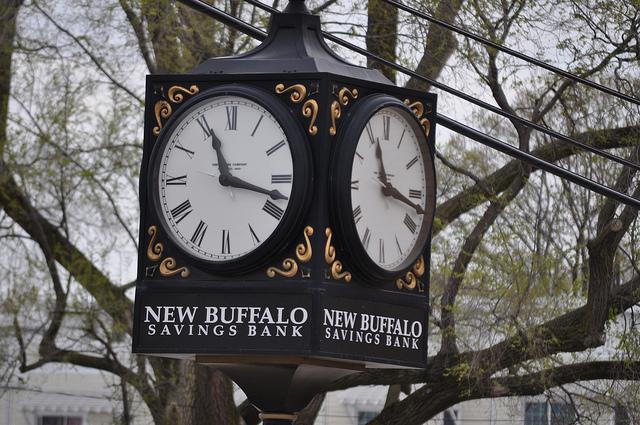How many clocks can be seen?
Give a very brief answer. 2. 